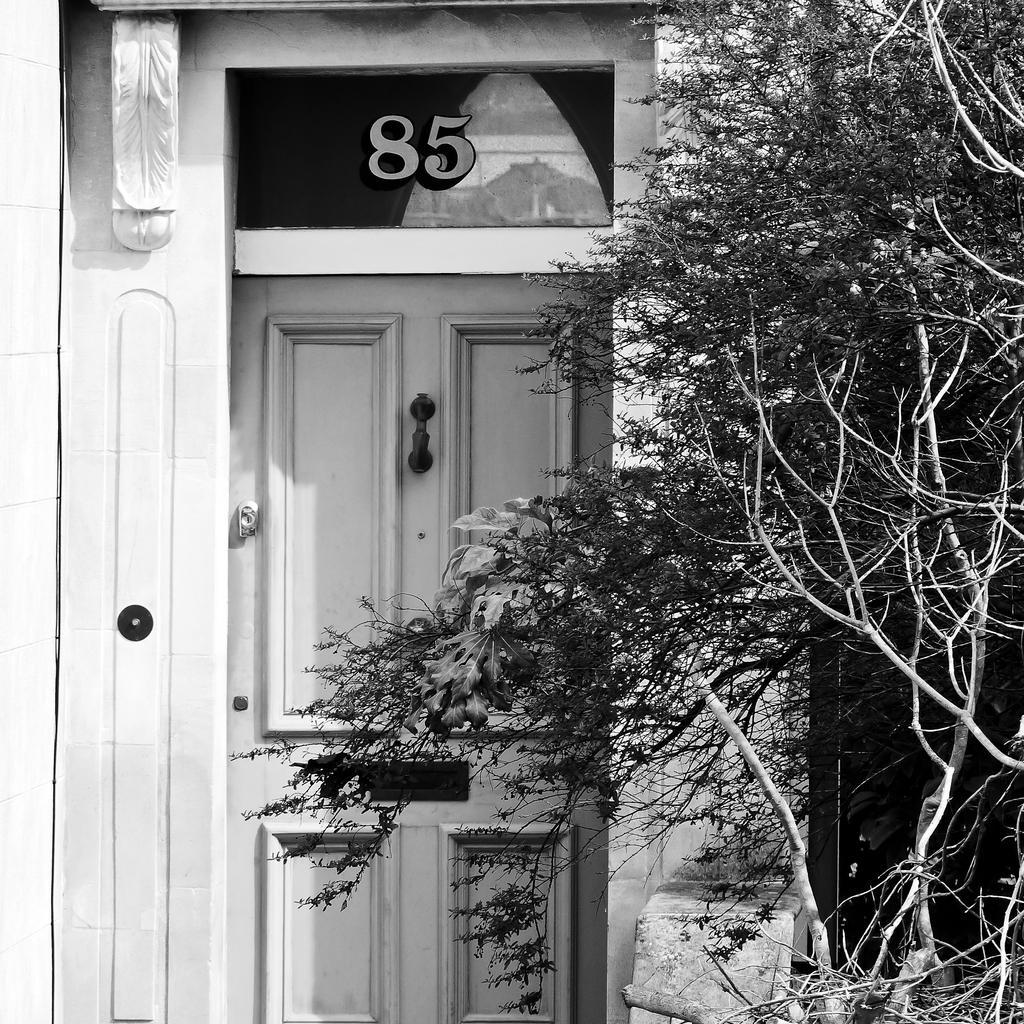Can you describe this image briefly? In the picture we can see a house door which is white in color and on the top of it we can see a number 85 and besides the door we can see some plants. 